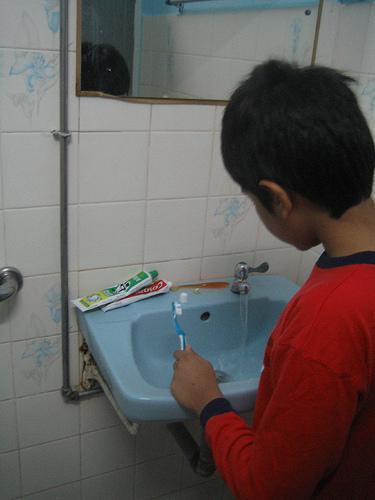How many people are in the photo?
Give a very brief answer. 1. How many mirrors are in the room?
Give a very brief answer. 1. How many tubes of toothpaste are on the sink?
Give a very brief answer. 2. How many toothbrushes is this?
Give a very brief answer. 2. How many sinks are in the photo?
Give a very brief answer. 1. How many people have ski gear?
Give a very brief answer. 0. 